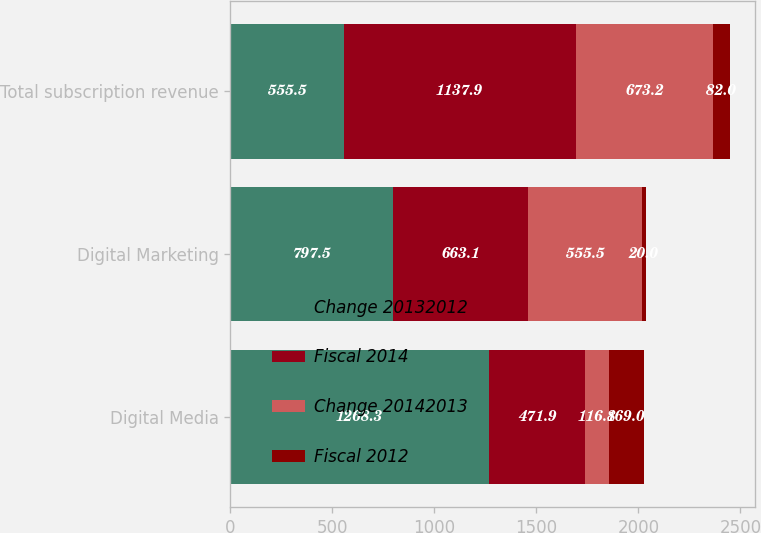Convert chart to OTSL. <chart><loc_0><loc_0><loc_500><loc_500><stacked_bar_chart><ecel><fcel>Digital Media<fcel>Digital Marketing<fcel>Total subscription revenue<nl><fcel>Change 20132012<fcel>1268.3<fcel>797.5<fcel>555.5<nl><fcel>Fiscal 2014<fcel>471.9<fcel>663.1<fcel>1137.9<nl><fcel>Change 20142013<fcel>116.8<fcel>555.5<fcel>673.2<nl><fcel>Fiscal 2012<fcel>169<fcel>20<fcel>82<nl></chart> 